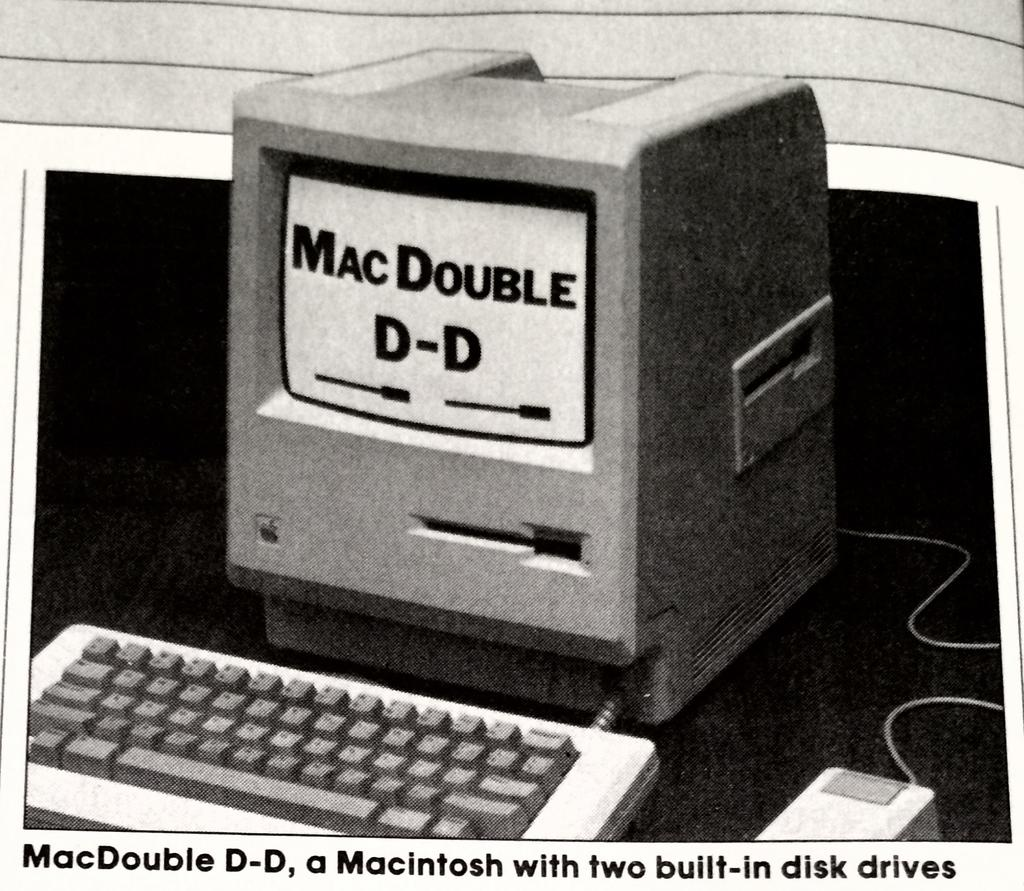<image>
Render a clear and concise summary of the photo. An old computer that says Mac Double D-D on the screen. 